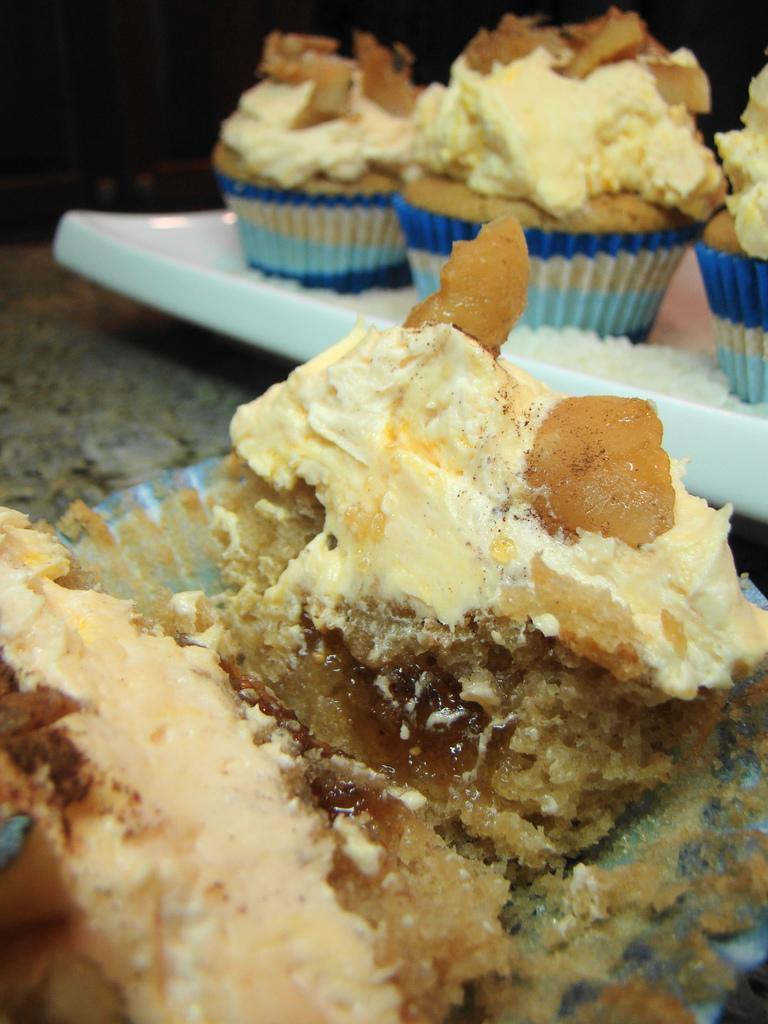Please provide a concise description of this image. In this image I can see few cupcakes on the white color surface. In front I can see the food on the grey color surface. 